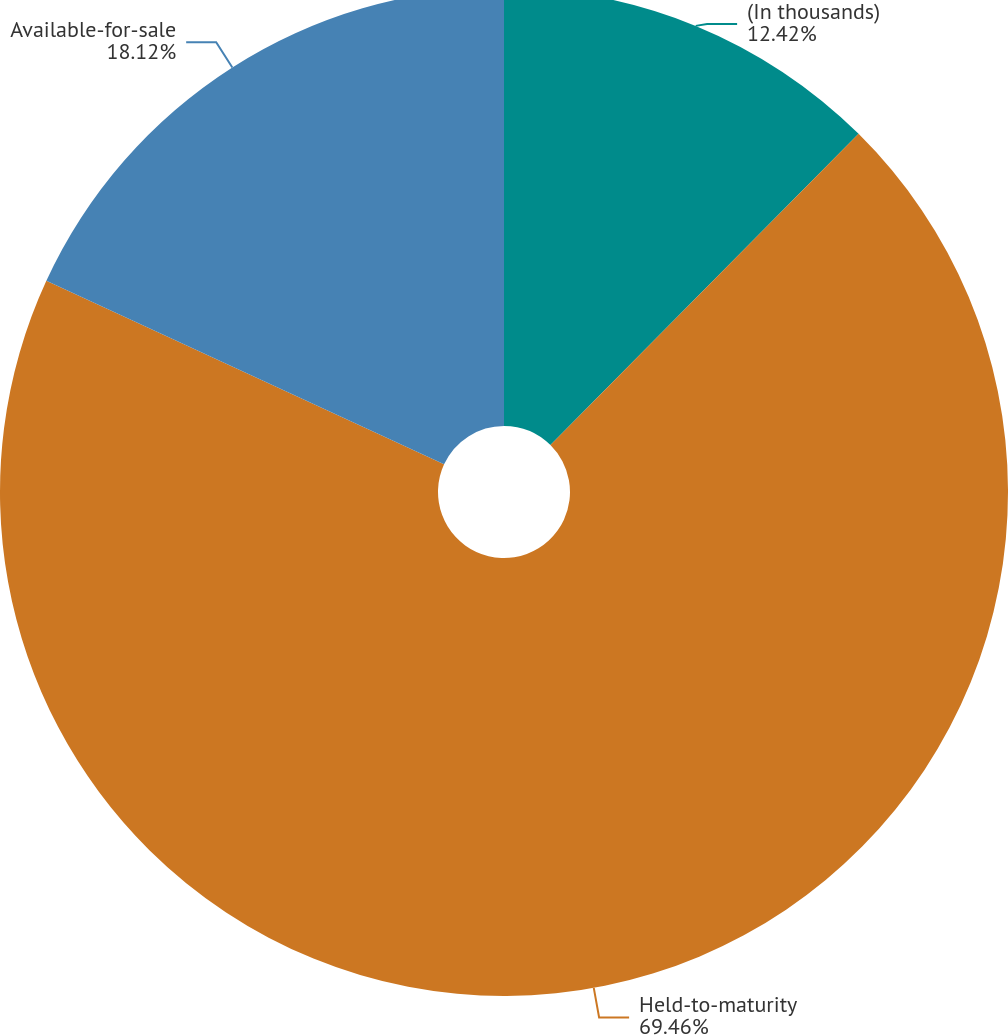Convert chart to OTSL. <chart><loc_0><loc_0><loc_500><loc_500><pie_chart><fcel>(In thousands)<fcel>Held-to-maturity<fcel>Available-for-sale<nl><fcel>12.42%<fcel>69.46%<fcel>18.12%<nl></chart> 